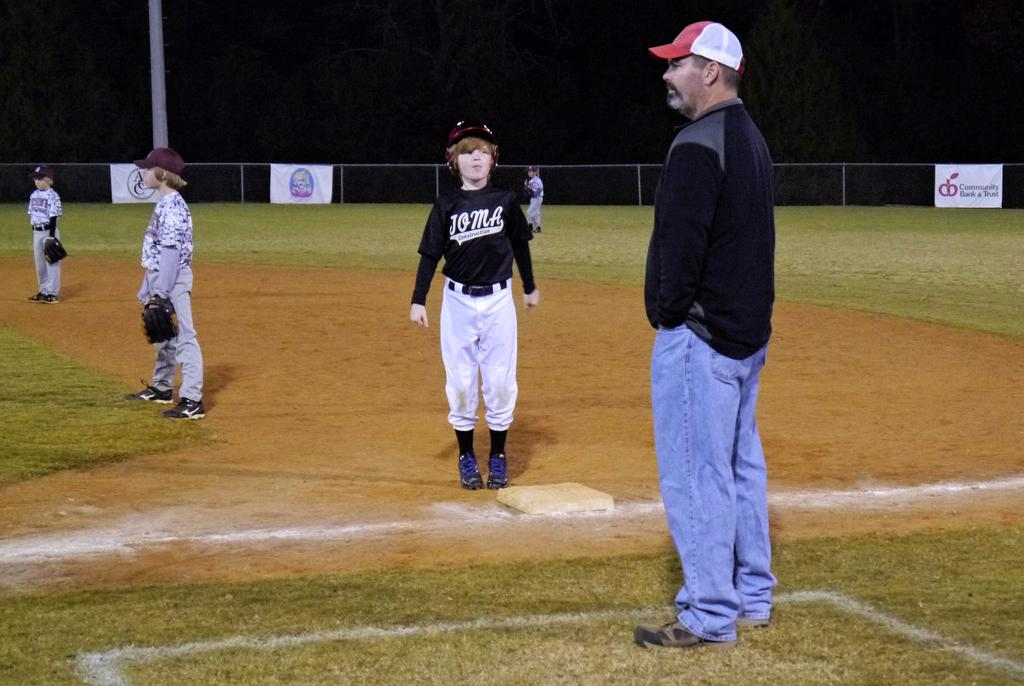<image>
Create a compact narrative representing the image presented. a boy standing at first base wit a Joma shirt on 